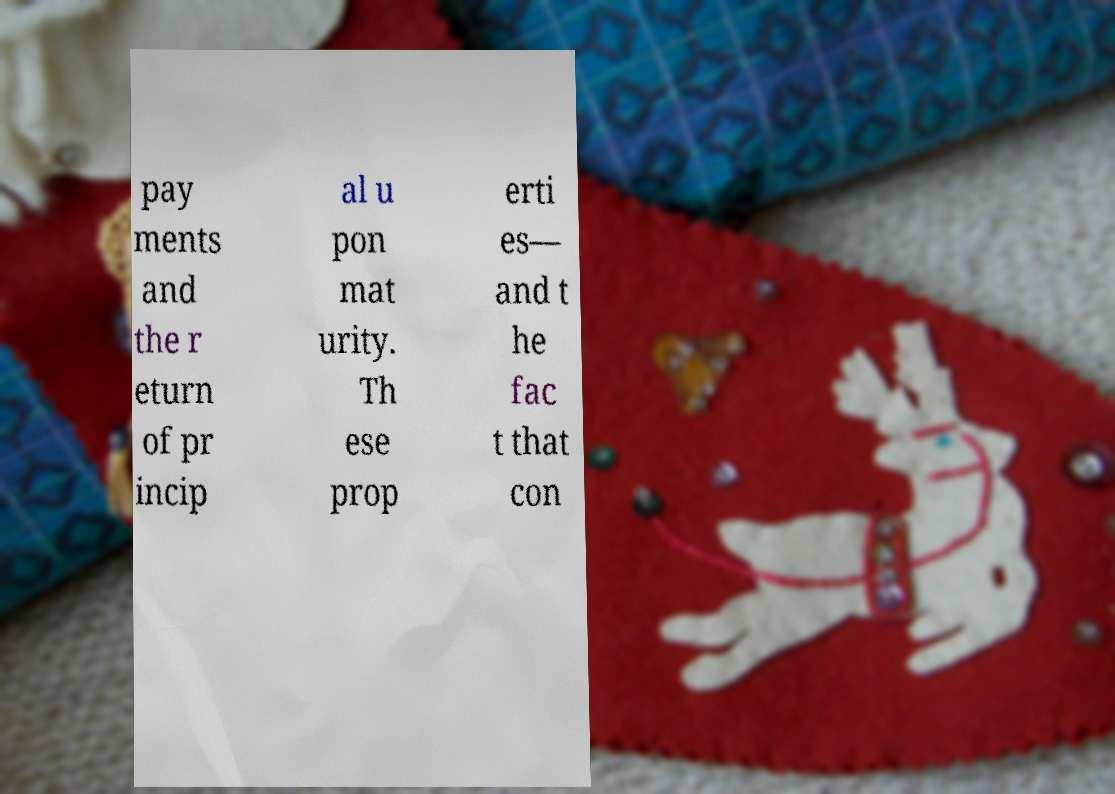Could you extract and type out the text from this image? pay ments and the r eturn of pr incip al u pon mat urity. Th ese prop erti es— and t he fac t that con 